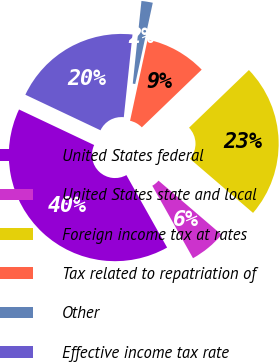Convert chart. <chart><loc_0><loc_0><loc_500><loc_500><pie_chart><fcel>United States federal<fcel>United States state and local<fcel>Foreign income tax at rates<fcel>Tax related to repatriation of<fcel>Other<fcel>Effective income tax rate<nl><fcel>40.18%<fcel>5.57%<fcel>23.48%<fcel>9.41%<fcel>1.72%<fcel>19.63%<nl></chart> 